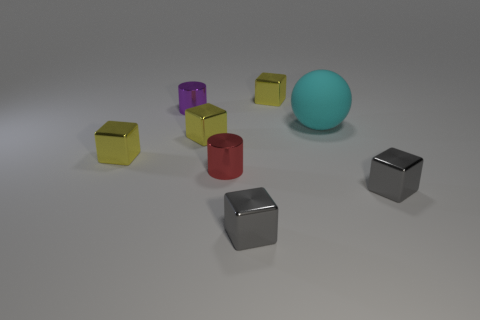Subtract all brown balls. How many yellow blocks are left? 3 Subtract all brown blocks. Subtract all cyan cylinders. How many blocks are left? 5 Add 2 cyan matte things. How many objects exist? 10 Subtract all spheres. How many objects are left? 7 Subtract 0 green cubes. How many objects are left? 8 Subtract all small brown blocks. Subtract all tiny purple objects. How many objects are left? 7 Add 7 purple cylinders. How many purple cylinders are left? 8 Add 3 small metal blocks. How many small metal blocks exist? 8 